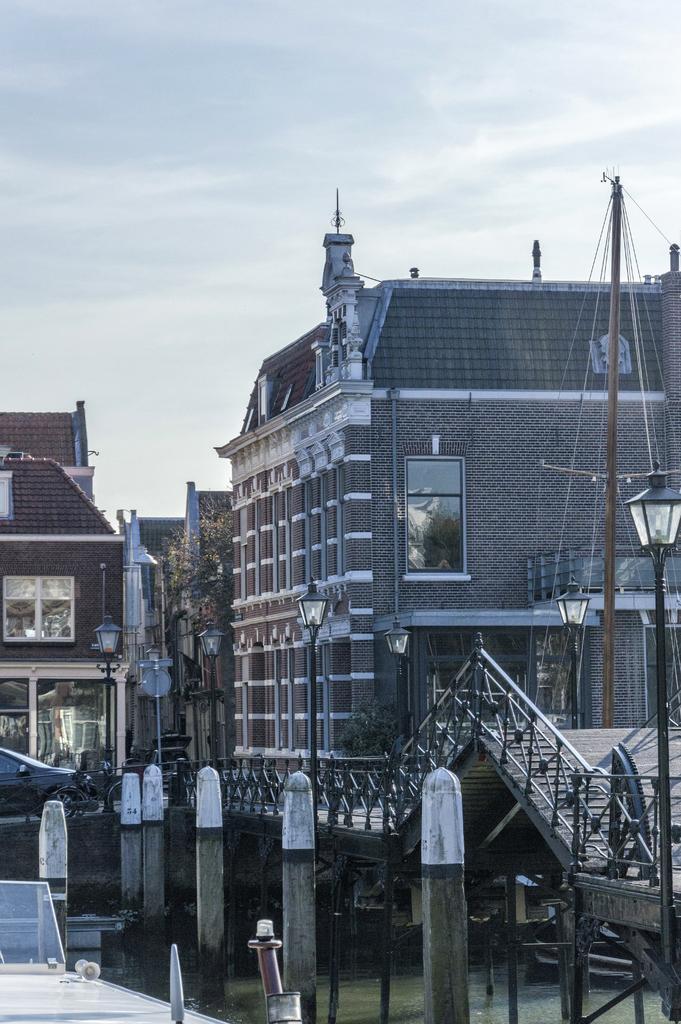Please provide a concise description of this image. In this image I can see the water, background I can see few light poles, stairs, buildings in brown and gray color, few glass windows and the sky is in white color. 